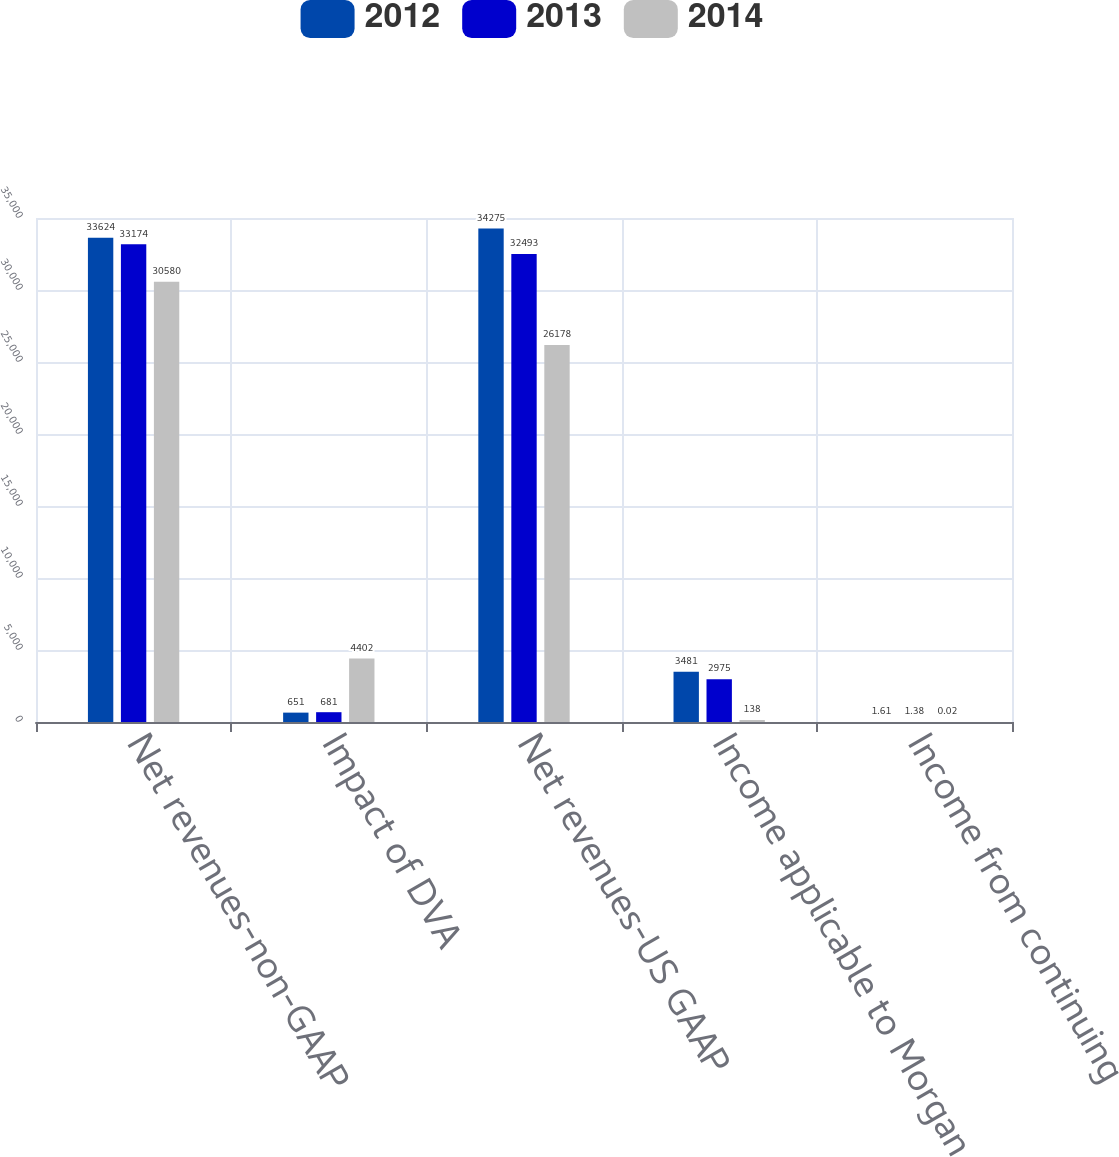Convert chart to OTSL. <chart><loc_0><loc_0><loc_500><loc_500><stacked_bar_chart><ecel><fcel>Net revenues-non-GAAP<fcel>Impact of DVA<fcel>Net revenues-US GAAP<fcel>Income applicable to Morgan<fcel>Income from continuing<nl><fcel>2012<fcel>33624<fcel>651<fcel>34275<fcel>3481<fcel>1.61<nl><fcel>2013<fcel>33174<fcel>681<fcel>32493<fcel>2975<fcel>1.38<nl><fcel>2014<fcel>30580<fcel>4402<fcel>26178<fcel>138<fcel>0.02<nl></chart> 